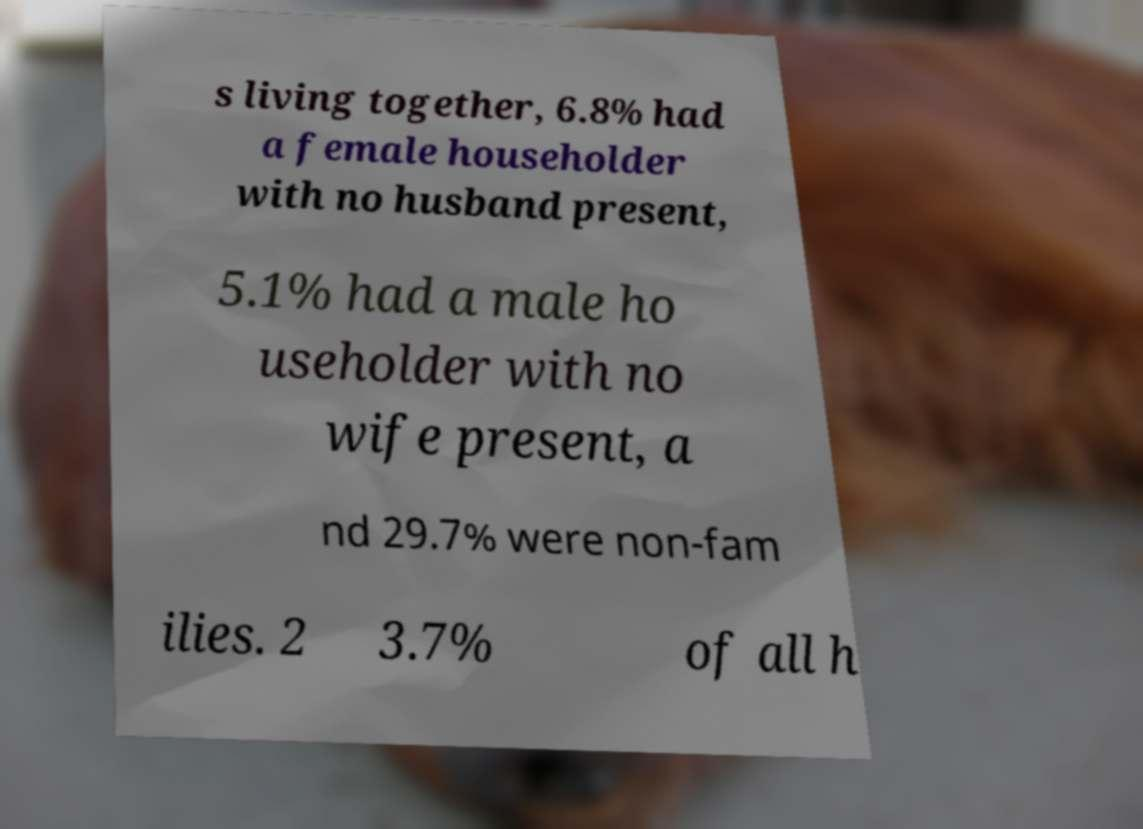Please identify and transcribe the text found in this image. s living together, 6.8% had a female householder with no husband present, 5.1% had a male ho useholder with no wife present, a nd 29.7% were non-fam ilies. 2 3.7% of all h 